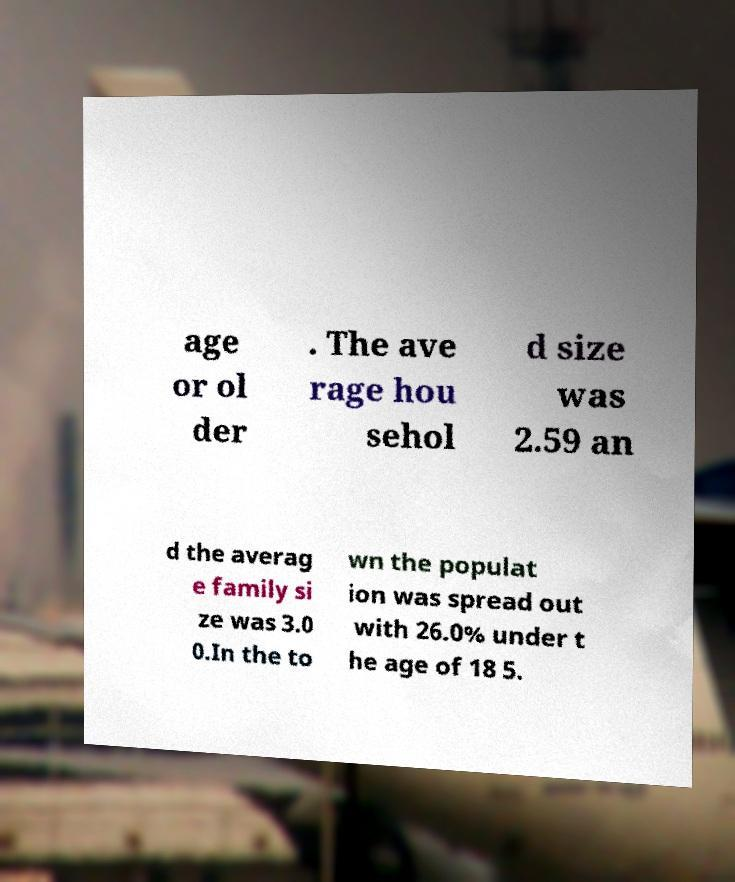Could you extract and type out the text from this image? age or ol der . The ave rage hou sehol d size was 2.59 an d the averag e family si ze was 3.0 0.In the to wn the populat ion was spread out with 26.0% under t he age of 18 5. 